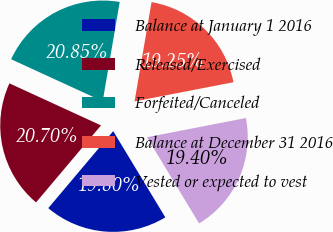Convert chart. <chart><loc_0><loc_0><loc_500><loc_500><pie_chart><fcel>Balance at January 1 2016<fcel>Released/Exercised<fcel>Forfeited/Canceled<fcel>Balance at December 31 2016<fcel>Vested or expected to vest<nl><fcel>19.8%<fcel>20.7%<fcel>20.85%<fcel>19.25%<fcel>19.4%<nl></chart> 